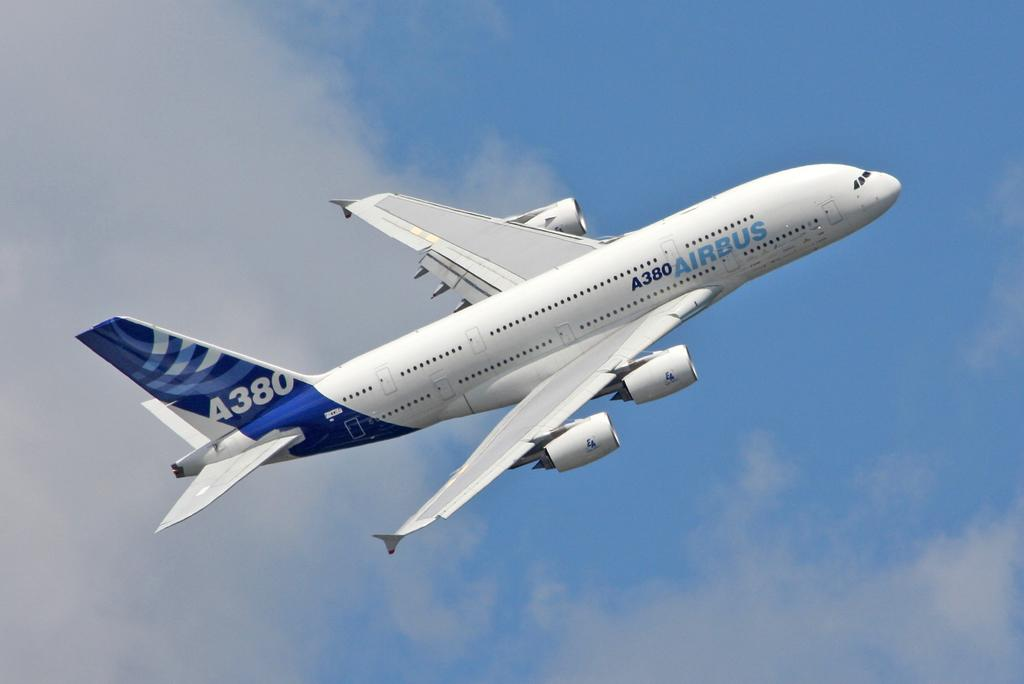<image>
Create a compact narrative representing the image presented. A A380 Airbus is flying high in the air. 